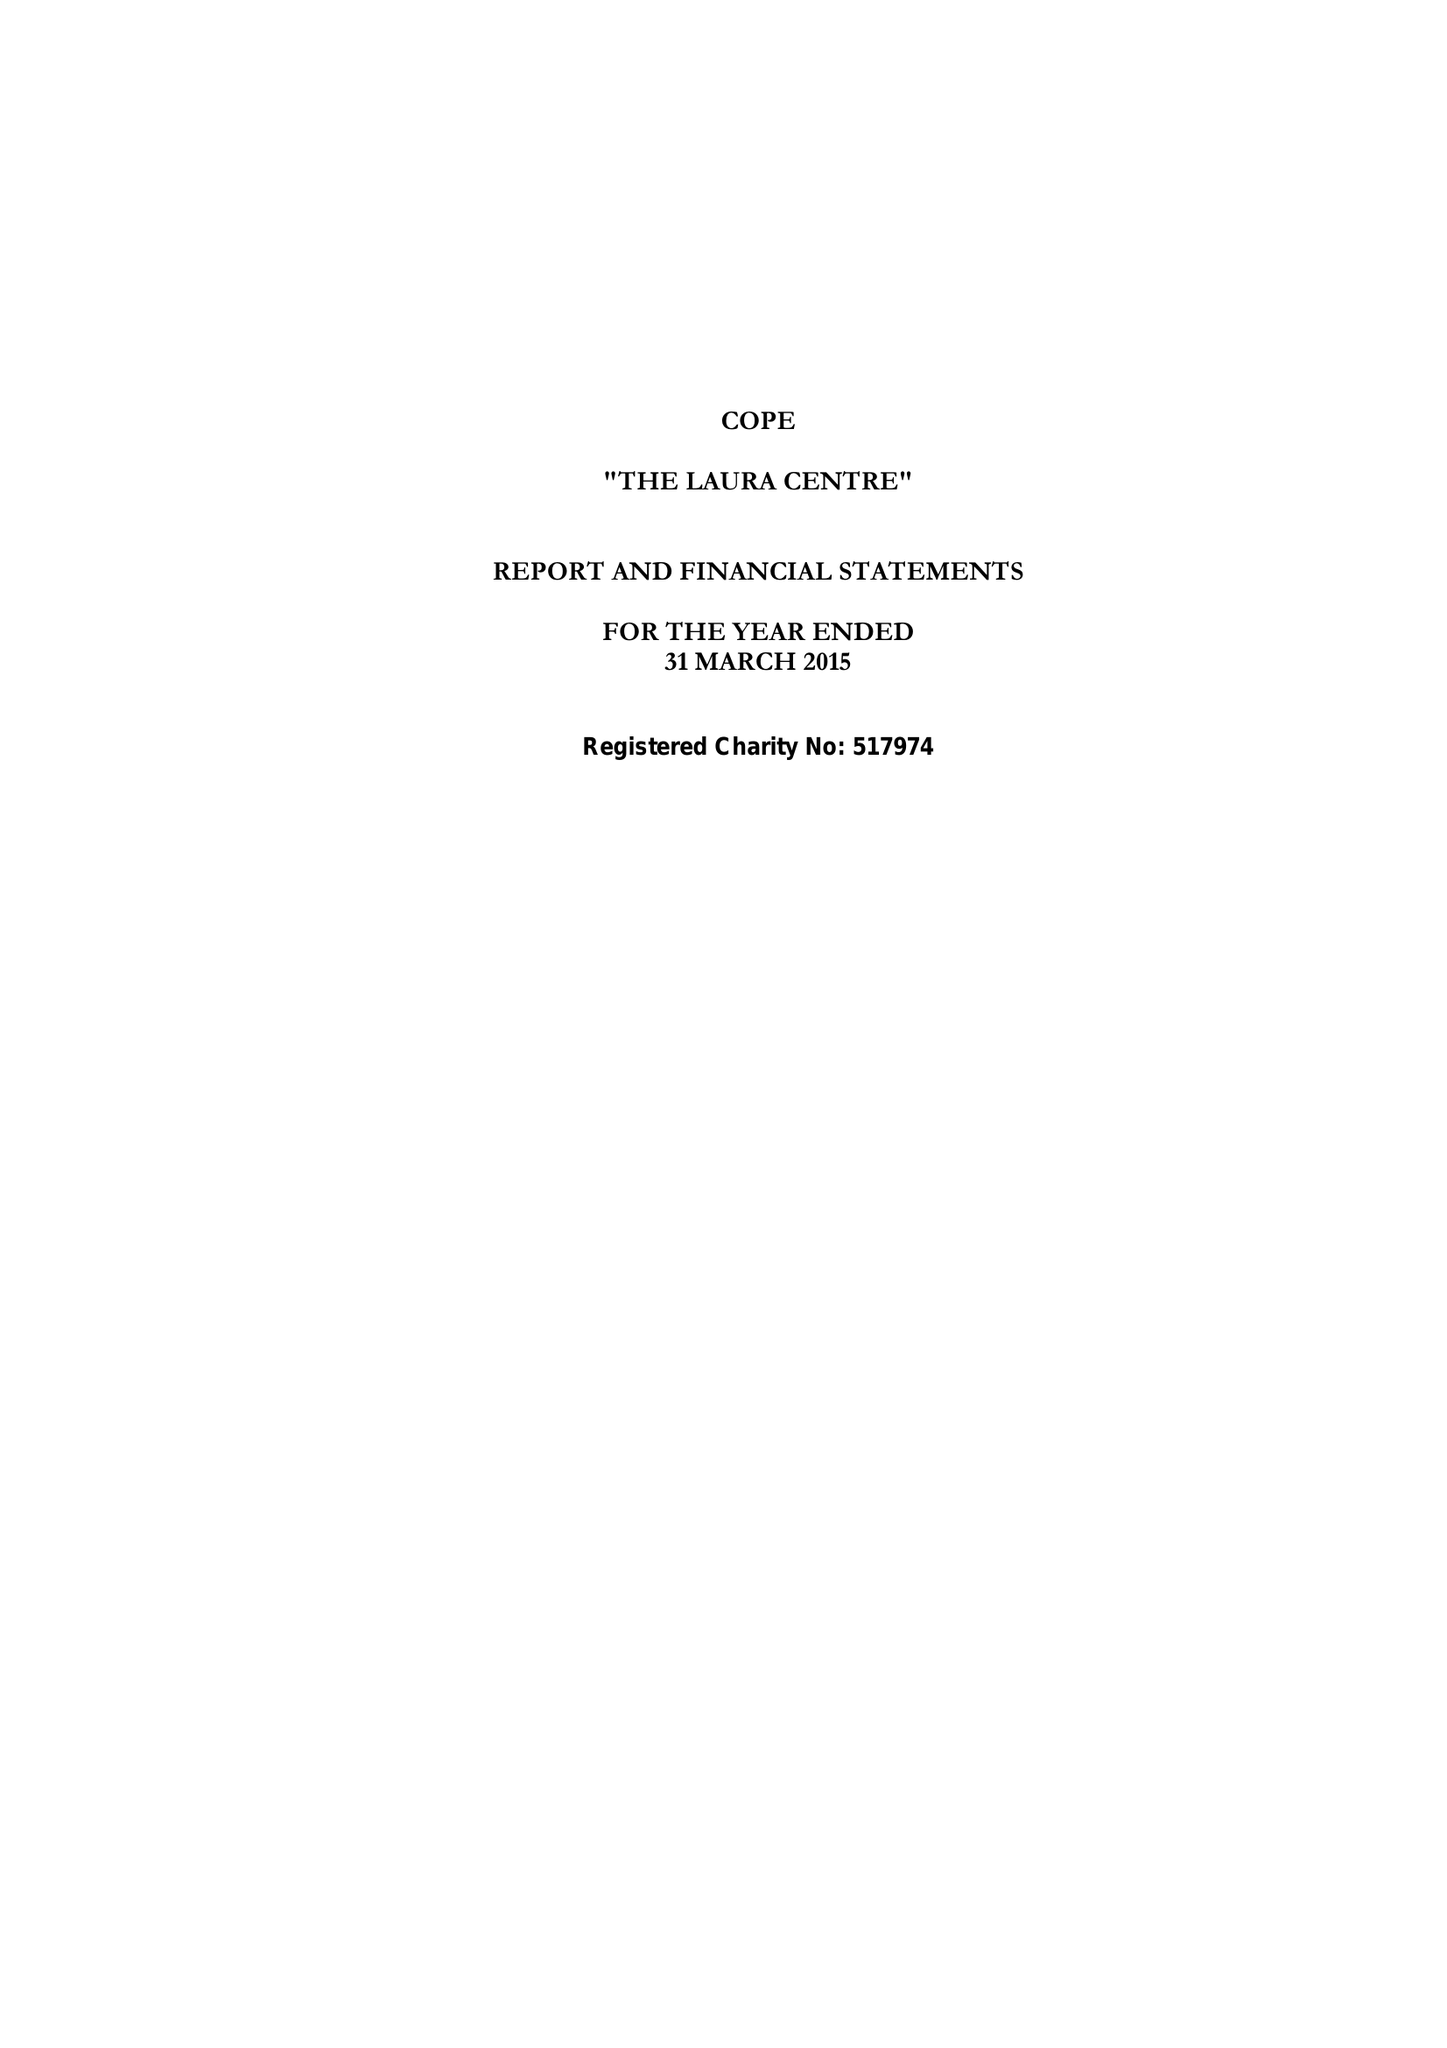What is the value for the spending_annually_in_british_pounds?
Answer the question using a single word or phrase. 464912.00 